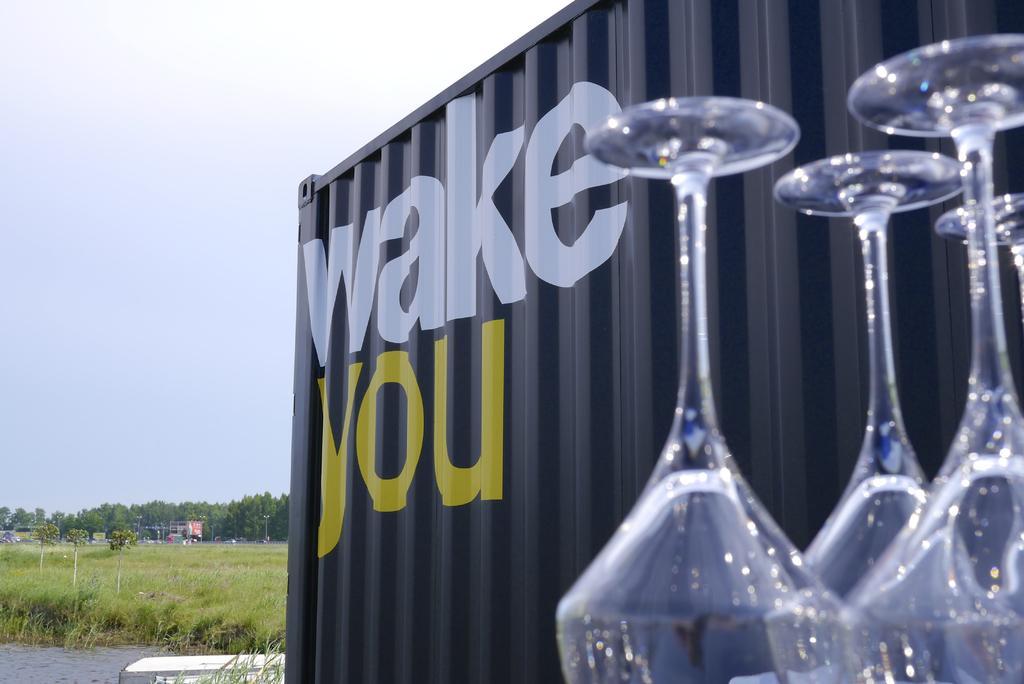Please provide a concise description of this image. We can see glasses and a metal thing present on the right side of this image and the sky is in the background. There is a field and trees are present at the bottom of this image. 